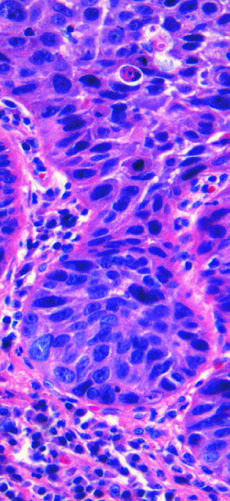s squamous cell carcinoma composed of nests of malignant cells that partially recapitulate the stratified organization of squamous epithelium?
Answer the question using a single word or phrase. Yes 